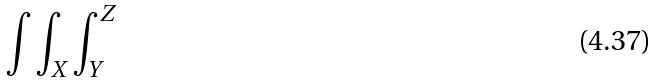<formula> <loc_0><loc_0><loc_500><loc_500>\int \int _ { X } \int _ { Y } ^ { Z }</formula> 